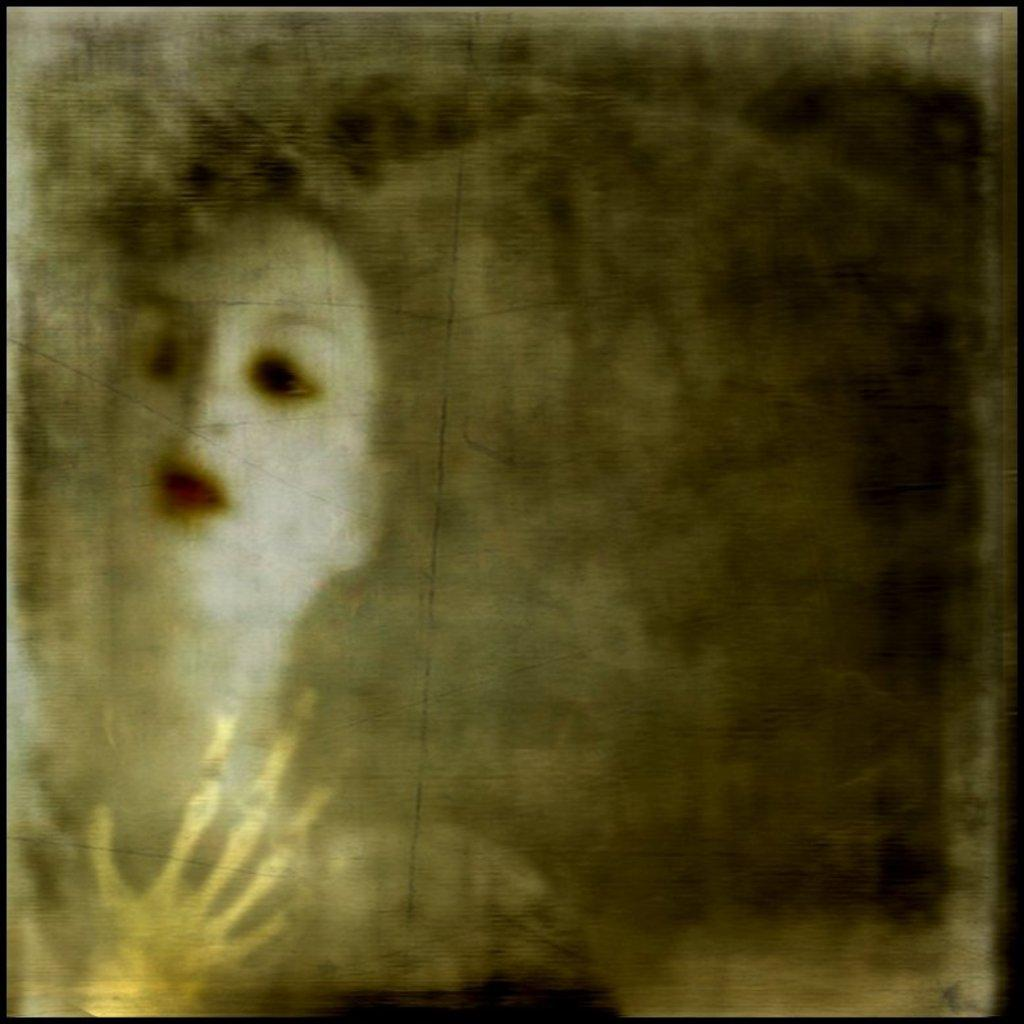Who is the main subject in the image? There is a lady in the image. Can you describe the appearance of the lady's face? The lady has a white face. What additional object can be seen in the bottom left of the image? There is a skeleton of a human hand in the bottom left of the image. What type of grass is growing around the lady in the image? There is no grass present in the image. 